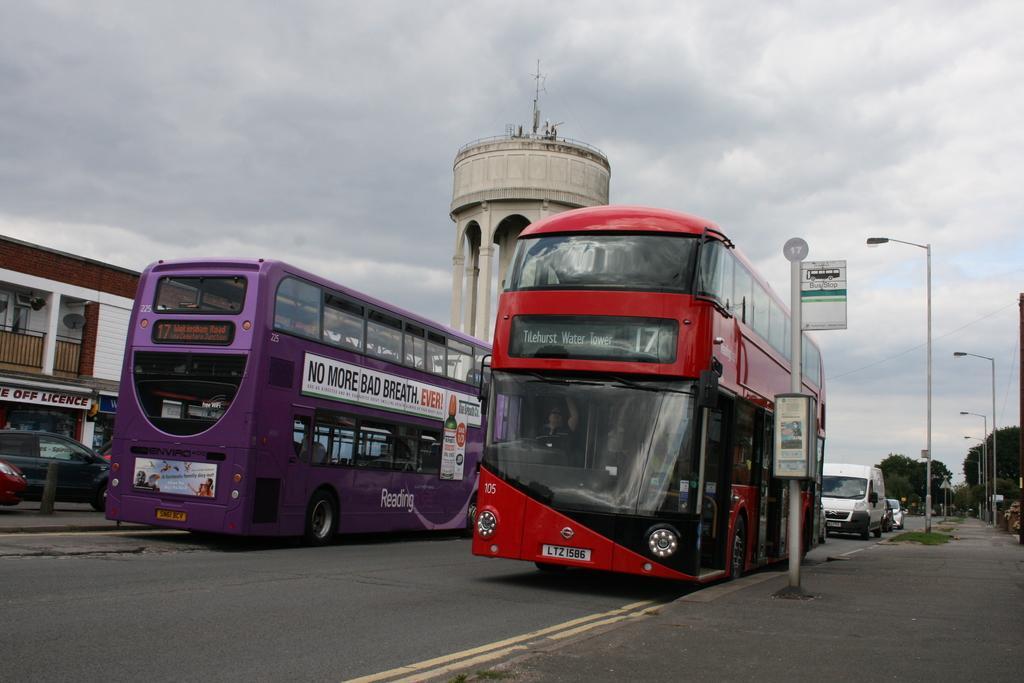Could you give a brief overview of what you see in this image? In this image we can see some vehicles on the road. We can also see a building, a divider pole, street poles, the sign boards with some text on them, grass, a tower with pillars, trees and the sky which looks cloudy. 